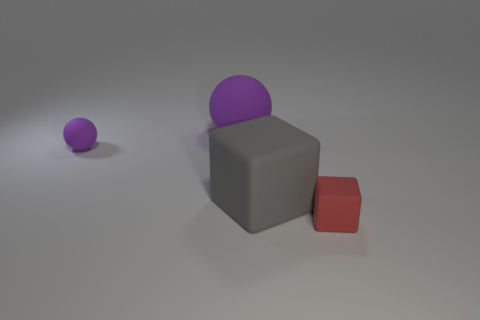How many blocks are large purple rubber things or big things?
Your answer should be compact. 1. There is a small thing behind the tiny matte object that is to the right of the gray rubber object; what color is it?
Your answer should be compact. Purple. Is the color of the big rubber sphere the same as the tiny rubber object to the left of the red matte thing?
Provide a short and direct response. Yes. What size is the purple thing that is the same material as the big sphere?
Provide a short and direct response. Small. What size is the rubber object that is the same color as the large sphere?
Offer a very short reply. Small. Do the large matte ball and the small ball have the same color?
Offer a very short reply. Yes. Are there any large spheres left of the big matte thing in front of the sphere that is to the right of the tiny ball?
Your response must be concise. Yes. What number of other matte things have the same size as the red matte object?
Provide a short and direct response. 1. There is a cube that is right of the big block; does it have the same size as the gray object that is behind the red block?
Offer a terse response. No. There is a thing that is on the right side of the small purple thing and behind the big gray thing; what is its shape?
Ensure brevity in your answer.  Sphere. 